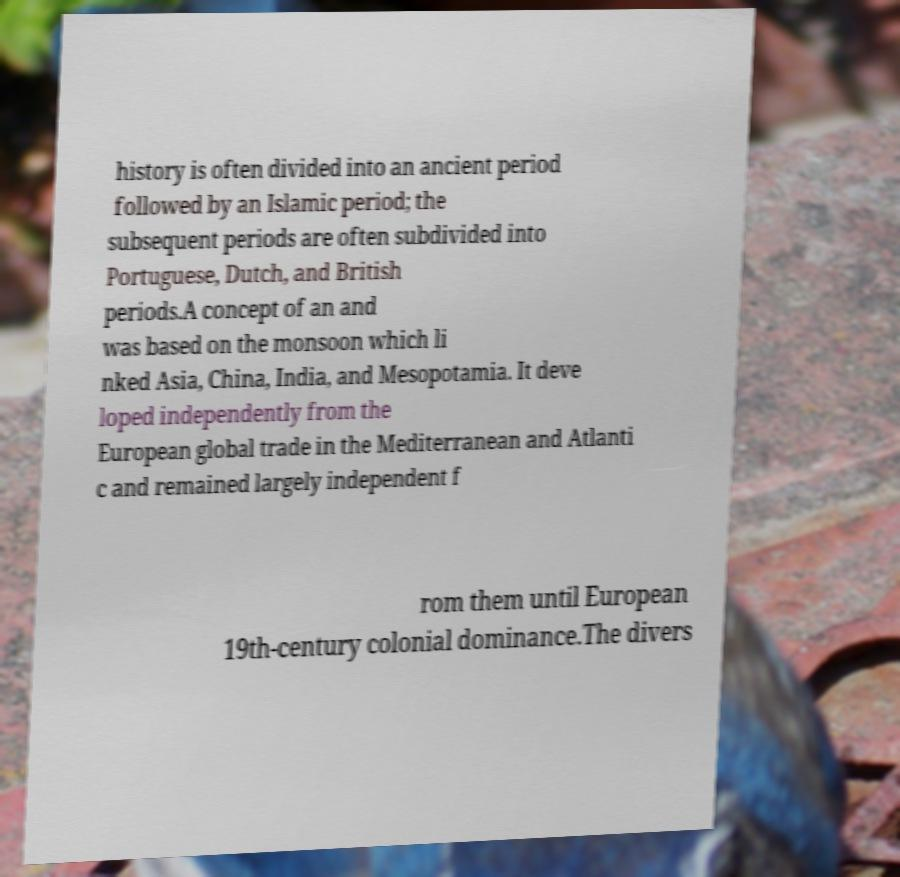For documentation purposes, I need the text within this image transcribed. Could you provide that? history is often divided into an ancient period followed by an Islamic period; the subsequent periods are often subdivided into Portuguese, Dutch, and British periods.A concept of an and was based on the monsoon which li nked Asia, China, India, and Mesopotamia. It deve loped independently from the European global trade in the Mediterranean and Atlanti c and remained largely independent f rom them until European 19th-century colonial dominance.The divers 